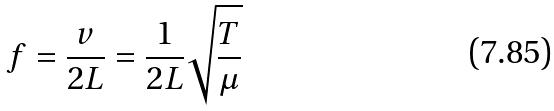<formula> <loc_0><loc_0><loc_500><loc_500>f = \frac { v } { 2 L } = \frac { 1 } { 2 L } \sqrt { \frac { T } { \mu } }</formula> 